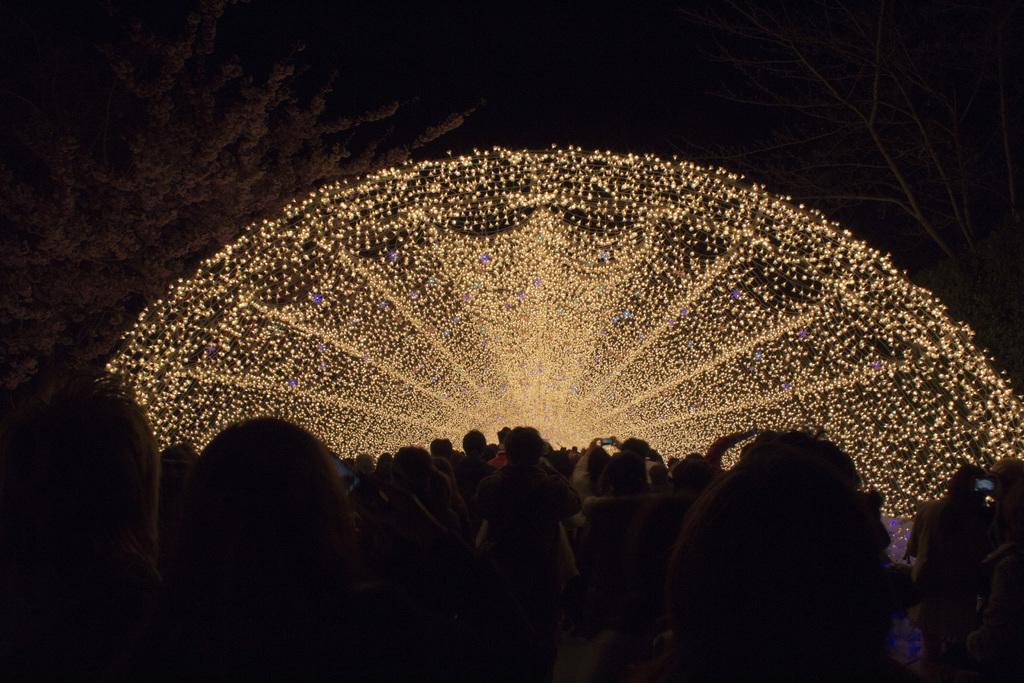Who or what is present in the image? There are people in the image. What can be seen at the top of the image? There are lights visible at the top of the image. What type of vegetation is on the left side of the image? There is a tree on the left side of the image. Are there any fairies visible in the image? There are no fairies present in the image. What type of sound can be heard coming from the tree in the image? There is no sound present in the image, as it is a still image and not a video or audio recording. 